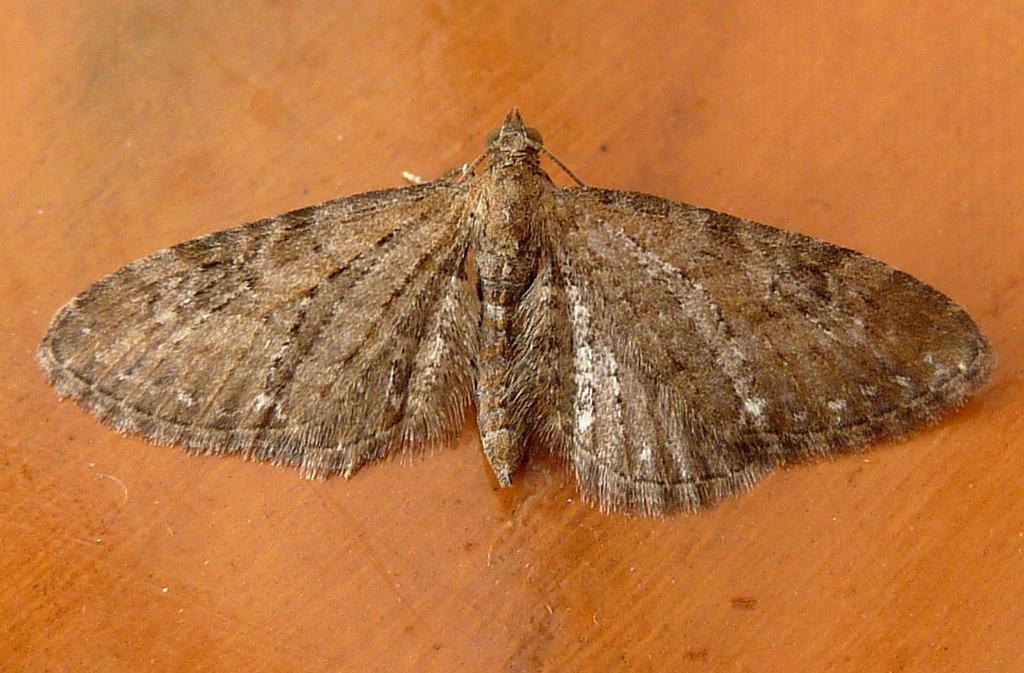Describe this image in one or two sentences. In this image, we can see a butterfly on the wooden surface. 